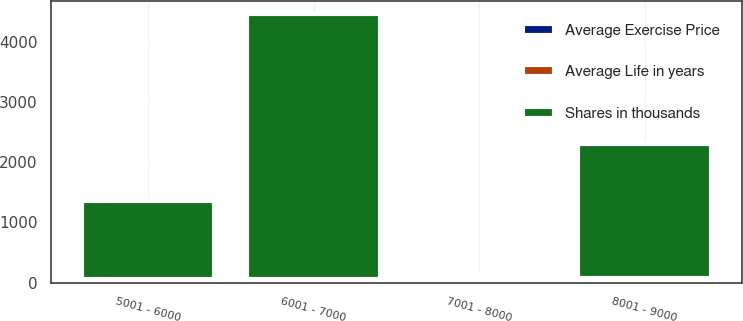<chart> <loc_0><loc_0><loc_500><loc_500><stacked_bar_chart><ecel><fcel>5001 - 6000<fcel>6001 - 7000<fcel>7001 - 8000<fcel>8001 - 9000<nl><fcel>Shares in thousands<fcel>1302<fcel>4396<fcel>61.58<fcel>2211<nl><fcel>Average Exercise Price<fcel>1.81<fcel>2.16<fcel>4.82<fcel>5.33<nl><fcel>Average Life in years<fcel>56.68<fcel>61.58<fcel>71.22<fcel>80.92<nl></chart> 